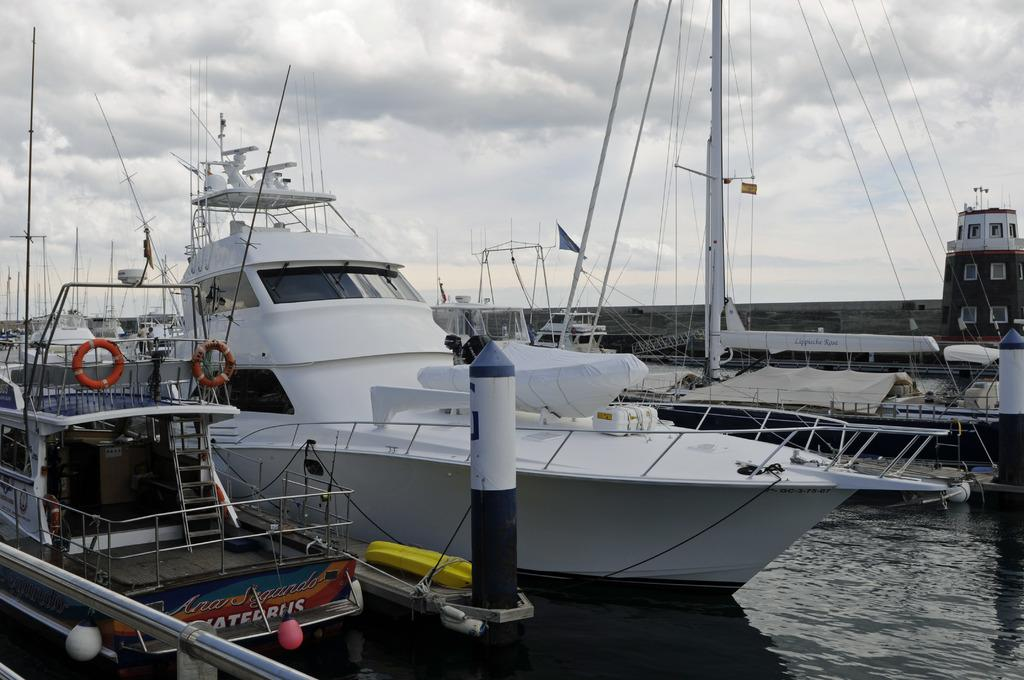What is on the water in the image? There are ships on the water in the image. What objects can be seen near the ships? Poles, swimming rings, and ropes are visible in the image. What is inside one of the ships? There is a carton box in one of the ships. What can be seen in the background of the image? There is a building and clouds visible in the sky in the background of the image. How many fingers can be seen pointing at the vessel in the image? There is no vessel present in the image, and therefore no fingers pointing at it. 